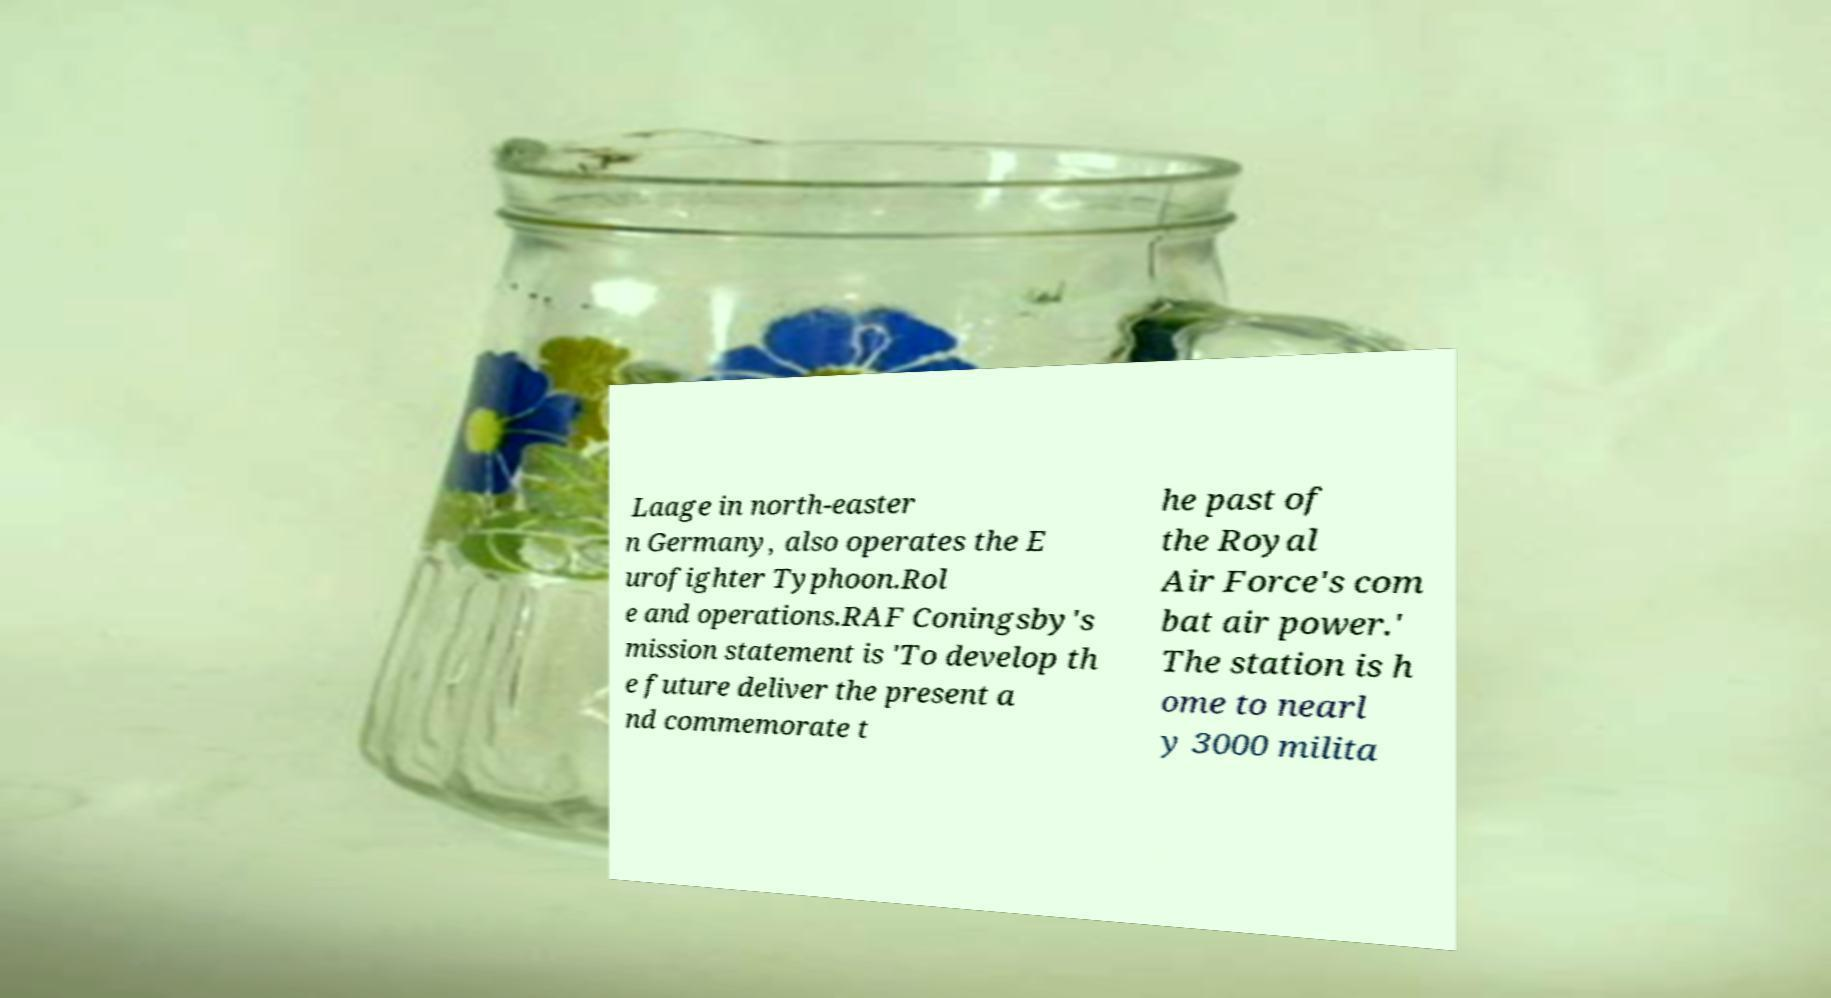For documentation purposes, I need the text within this image transcribed. Could you provide that? Laage in north-easter n Germany, also operates the E urofighter Typhoon.Rol e and operations.RAF Coningsby's mission statement is 'To develop th e future deliver the present a nd commemorate t he past of the Royal Air Force's com bat air power.' The station is h ome to nearl y 3000 milita 